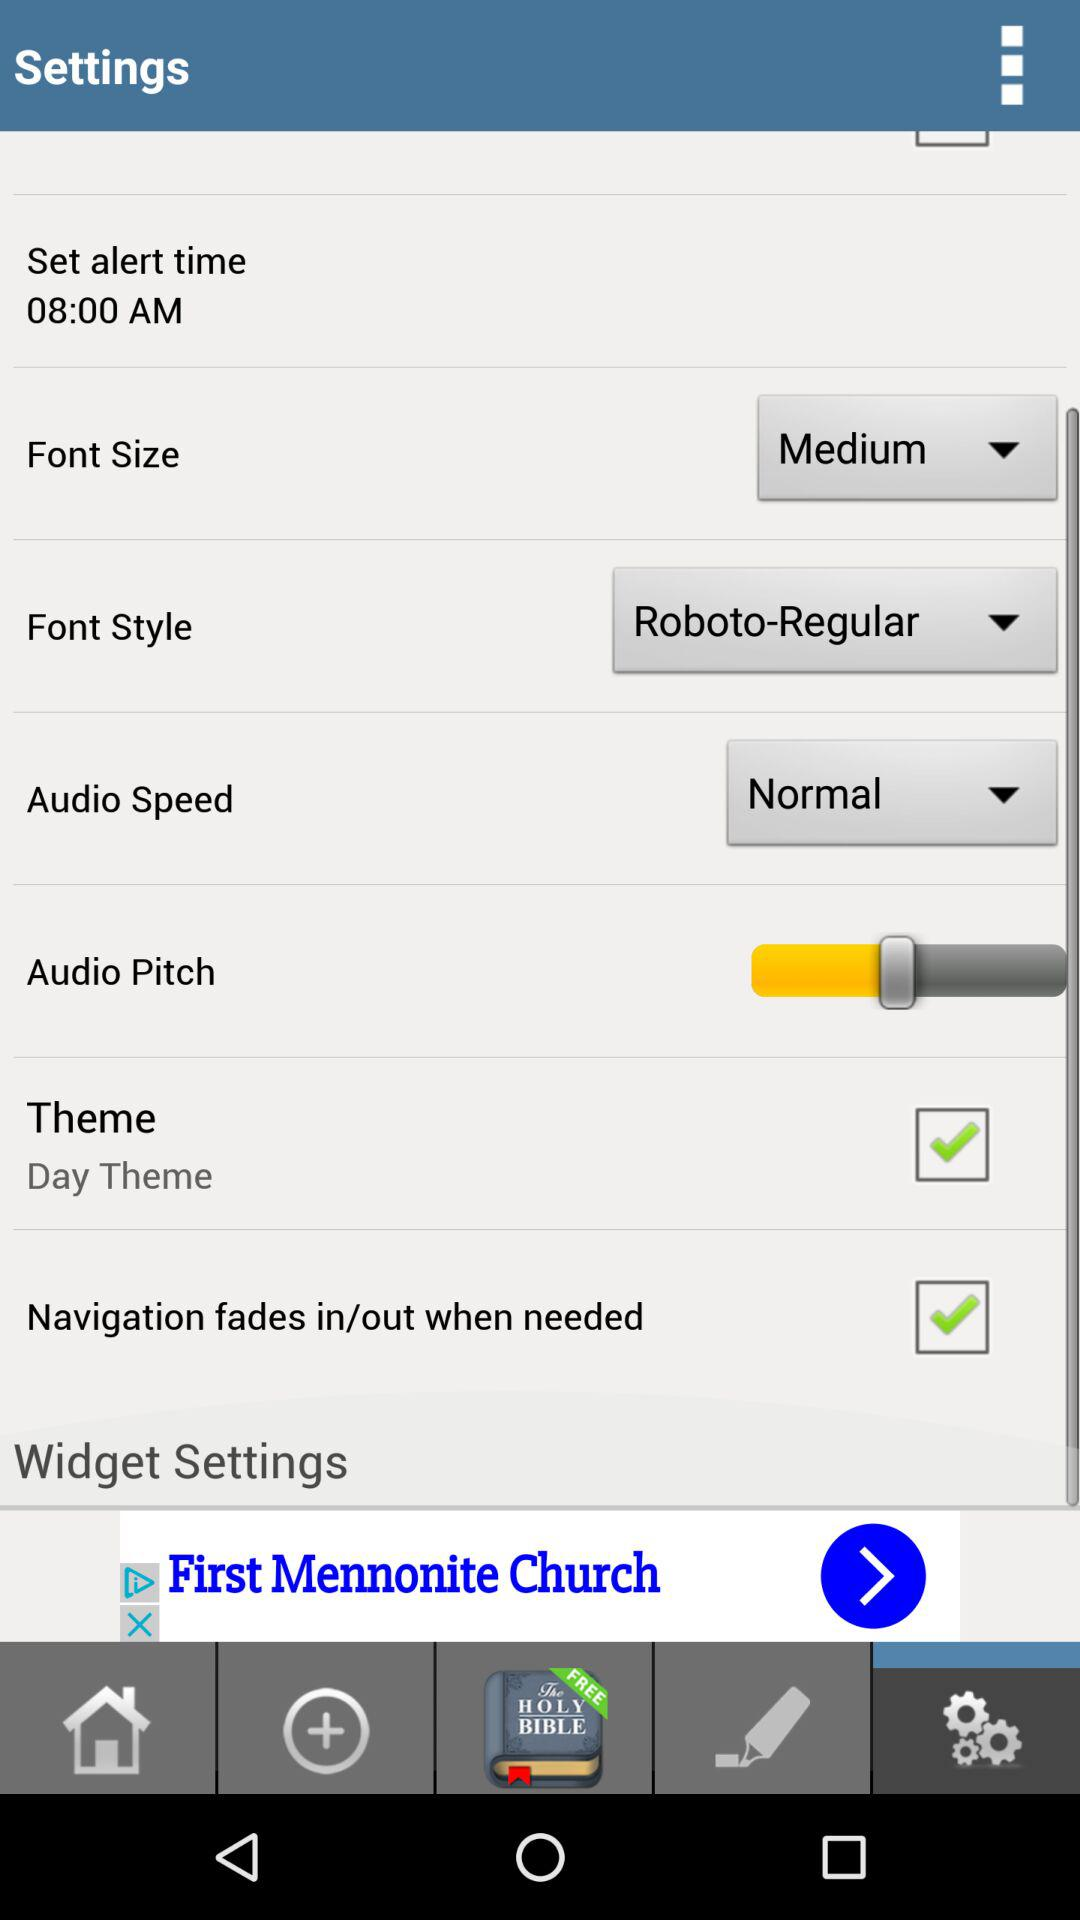What is the status of "Navigation fades in/out when needed"? The status is "on". 